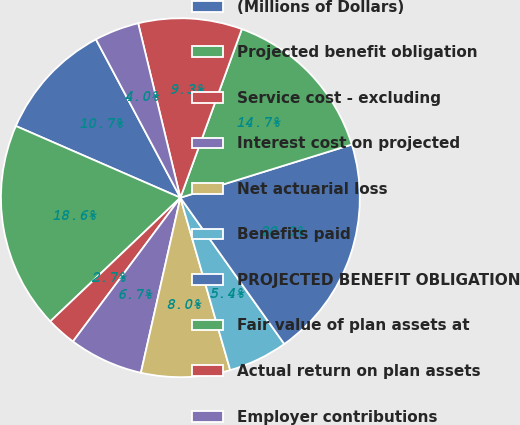<chart> <loc_0><loc_0><loc_500><loc_500><pie_chart><fcel>(Millions of Dollars)<fcel>Projected benefit obligation<fcel>Service cost - excluding<fcel>Interest cost on projected<fcel>Net actuarial loss<fcel>Benefits paid<fcel>PROJECTED BENEFIT OBLIGATION<fcel>Fair value of plan assets at<fcel>Actual return on plan assets<fcel>Employer contributions<nl><fcel>10.66%<fcel>18.64%<fcel>2.69%<fcel>6.68%<fcel>8.01%<fcel>5.35%<fcel>19.96%<fcel>14.65%<fcel>9.34%<fcel>4.02%<nl></chart> 